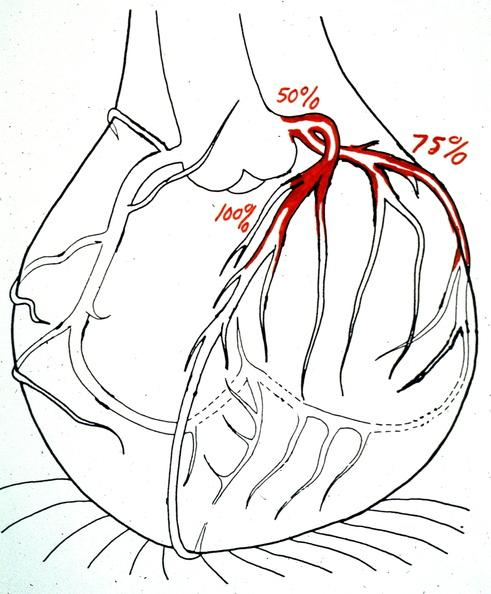does this image show heart, myocardial infarction, map of coronary artery lesions?
Answer the question using a single word or phrase. Yes 